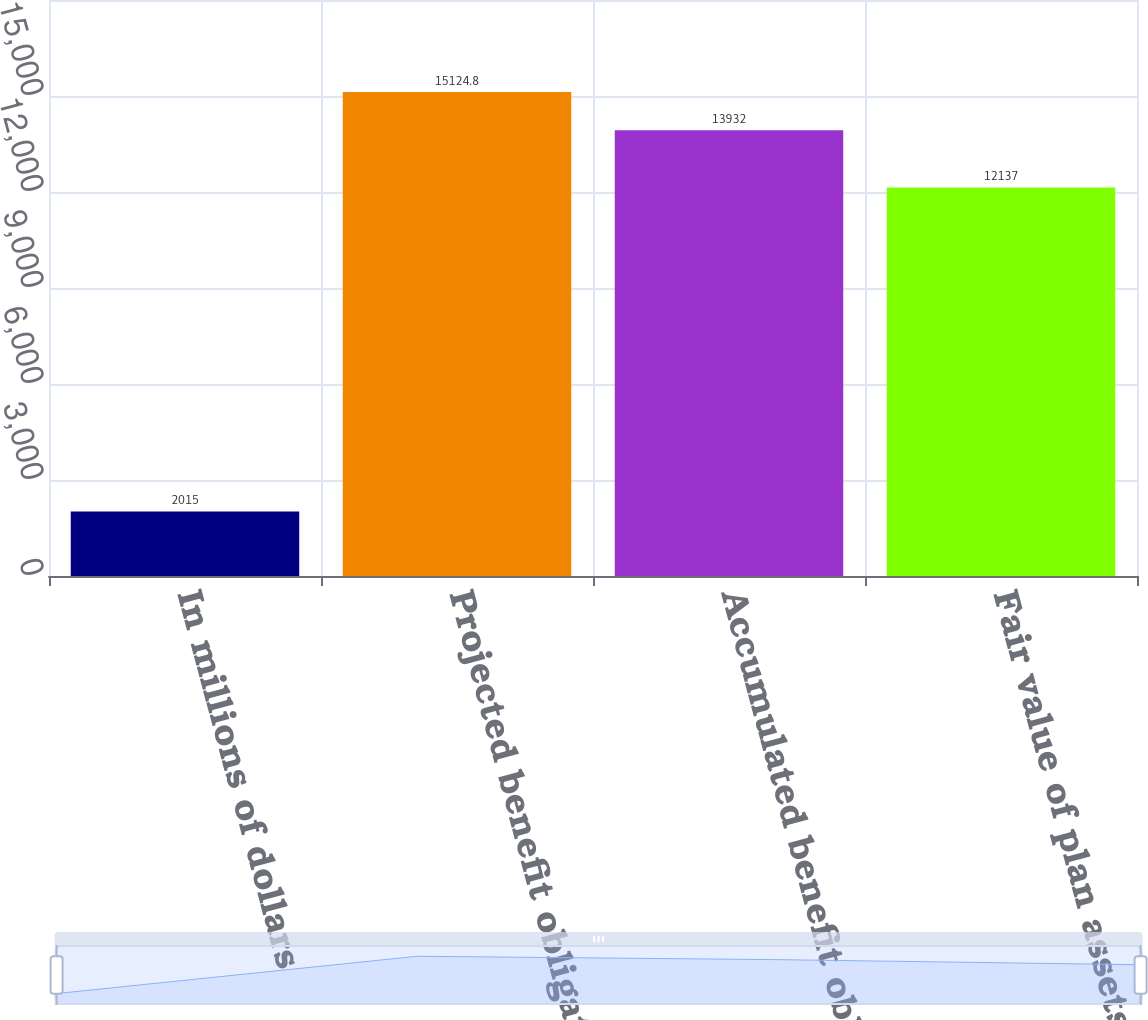Convert chart. <chart><loc_0><loc_0><loc_500><loc_500><bar_chart><fcel>In millions of dollars<fcel>Projected benefit obligation<fcel>Accumulated benefit obligation<fcel>Fair value of plan assets<nl><fcel>2015<fcel>15124.8<fcel>13932<fcel>12137<nl></chart> 